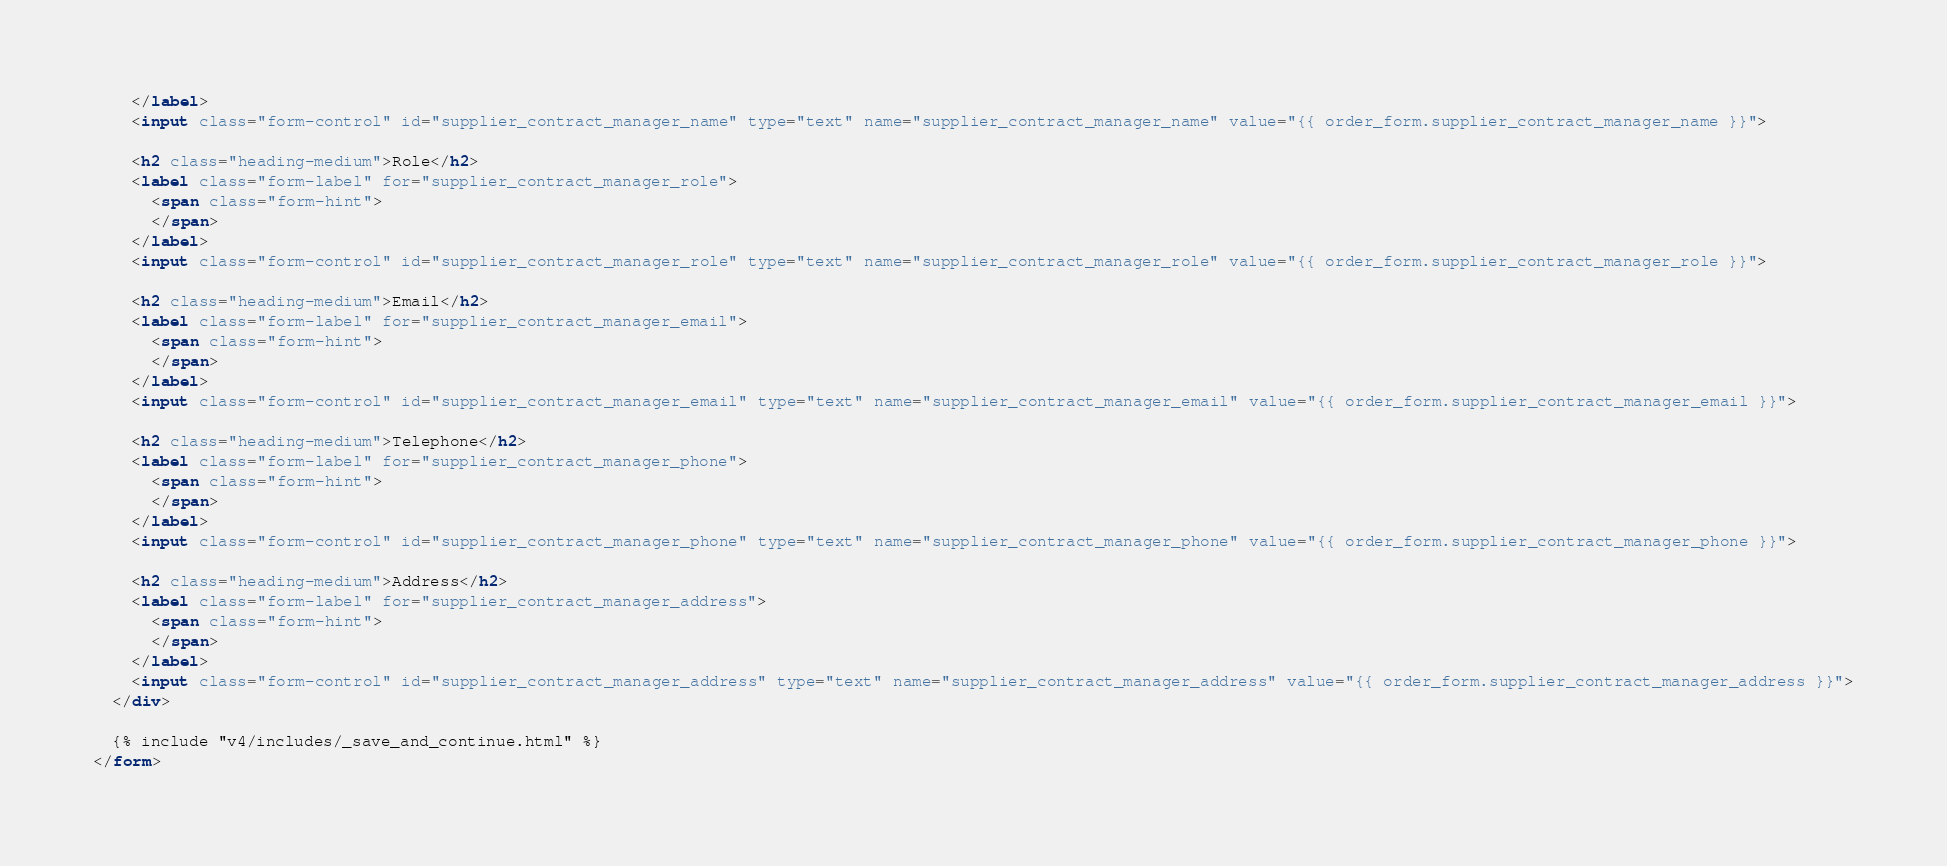<code> <loc_0><loc_0><loc_500><loc_500><_HTML_>    </label>
    <input class="form-control" id="supplier_contract_manager_name" type="text" name="supplier_contract_manager_name" value="{{ order_form.supplier_contract_manager_name }}">

    <h2 class="heading-medium">Role</h2>
    <label class="form-label" for="supplier_contract_manager_role">
      <span class="form-hint">
      </span>
    </label>
    <input class="form-control" id="supplier_contract_manager_role" type="text" name="supplier_contract_manager_role" value="{{ order_form.supplier_contract_manager_role }}">

    <h2 class="heading-medium">Email</h2>
    <label class="form-label" for="supplier_contract_manager_email">
      <span class="form-hint">
      </span>
    </label>
    <input class="form-control" id="supplier_contract_manager_email" type="text" name="supplier_contract_manager_email" value="{{ order_form.supplier_contract_manager_email }}">

    <h2 class="heading-medium">Telephone</h2>
    <label class="form-label" for="supplier_contract_manager_phone">
      <span class="form-hint">
      </span>
    </label>
    <input class="form-control" id="supplier_contract_manager_phone" type="text" name="supplier_contract_manager_phone" value="{{ order_form.supplier_contract_manager_phone }}">

    <h2 class="heading-medium">Address</h2>
    <label class="form-label" for="supplier_contract_manager_address">
      <span class="form-hint">
      </span>
    </label>
    <input class="form-control" id="supplier_contract_manager_address" type="text" name="supplier_contract_manager_address" value="{{ order_form.supplier_contract_manager_address }}">
  </div>

  {% include "v4/includes/_save_and_continue.html" %}
</form></code> 